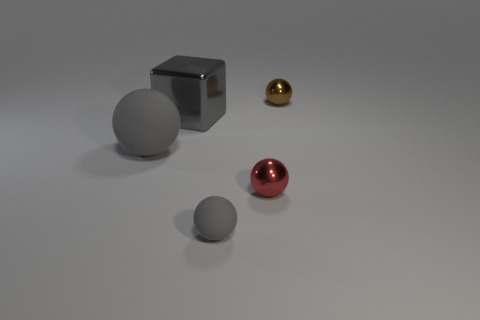Add 2 brown objects. How many objects exist? 7 Subtract all cubes. How many objects are left? 4 Add 5 red shiny balls. How many red shiny balls exist? 6 Subtract 0 red cylinders. How many objects are left? 5 Subtract all metallic blocks. Subtract all blue cylinders. How many objects are left? 4 Add 5 gray metal things. How many gray metal things are left? 6 